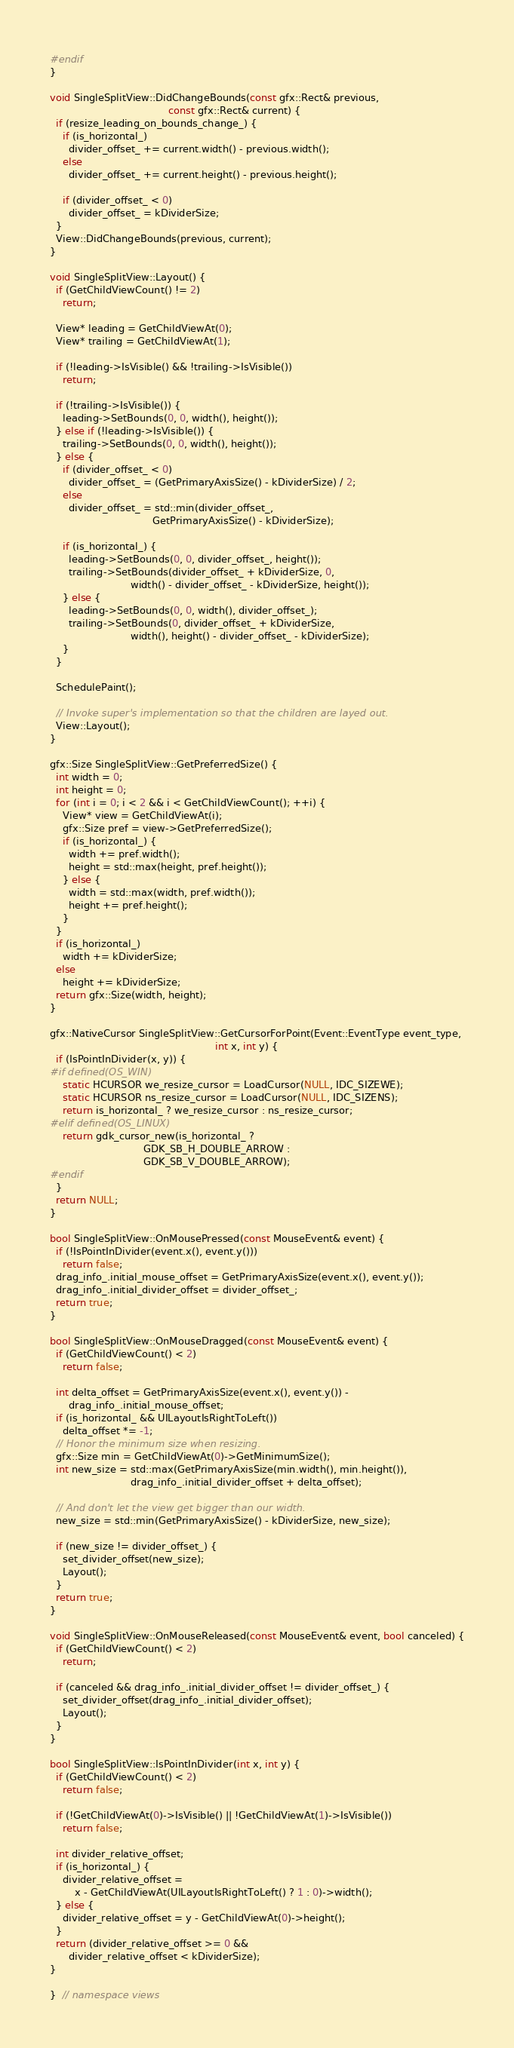<code> <loc_0><loc_0><loc_500><loc_500><_C++_>#endif
}

void SingleSplitView::DidChangeBounds(const gfx::Rect& previous,
                                      const gfx::Rect& current) {
  if (resize_leading_on_bounds_change_) {
    if (is_horizontal_)
      divider_offset_ += current.width() - previous.width();
    else
      divider_offset_ += current.height() - previous.height();

    if (divider_offset_ < 0)
      divider_offset_ = kDividerSize;
  }
  View::DidChangeBounds(previous, current);
}

void SingleSplitView::Layout() {
  if (GetChildViewCount() != 2)
    return;

  View* leading = GetChildViewAt(0);
  View* trailing = GetChildViewAt(1);

  if (!leading->IsVisible() && !trailing->IsVisible())
    return;

  if (!trailing->IsVisible()) {
    leading->SetBounds(0, 0, width(), height());
  } else if (!leading->IsVisible()) {
    trailing->SetBounds(0, 0, width(), height());
  } else {
    if (divider_offset_ < 0)
      divider_offset_ = (GetPrimaryAxisSize() - kDividerSize) / 2;
    else
      divider_offset_ = std::min(divider_offset_,
                                 GetPrimaryAxisSize() - kDividerSize);

    if (is_horizontal_) {
      leading->SetBounds(0, 0, divider_offset_, height());
      trailing->SetBounds(divider_offset_ + kDividerSize, 0,
                          width() - divider_offset_ - kDividerSize, height());
    } else {
      leading->SetBounds(0, 0, width(), divider_offset_);
      trailing->SetBounds(0, divider_offset_ + kDividerSize,
                          width(), height() - divider_offset_ - kDividerSize);
    }
  }

  SchedulePaint();

  // Invoke super's implementation so that the children are layed out.
  View::Layout();
}

gfx::Size SingleSplitView::GetPreferredSize() {
  int width = 0;
  int height = 0;
  for (int i = 0; i < 2 && i < GetChildViewCount(); ++i) {
    View* view = GetChildViewAt(i);
    gfx::Size pref = view->GetPreferredSize();
    if (is_horizontal_) {
      width += pref.width();
      height = std::max(height, pref.height());
    } else {
      width = std::max(width, pref.width());
      height += pref.height();
    }
  }
  if (is_horizontal_)
    width += kDividerSize;
  else
    height += kDividerSize;
  return gfx::Size(width, height);
}

gfx::NativeCursor SingleSplitView::GetCursorForPoint(Event::EventType event_type,
                                                     int x, int y) {
  if (IsPointInDivider(x, y)) {
#if defined(OS_WIN)
    static HCURSOR we_resize_cursor = LoadCursor(NULL, IDC_SIZEWE);
    static HCURSOR ns_resize_cursor = LoadCursor(NULL, IDC_SIZENS);
    return is_horizontal_ ? we_resize_cursor : ns_resize_cursor;
#elif defined(OS_LINUX)
    return gdk_cursor_new(is_horizontal_ ?
                              GDK_SB_H_DOUBLE_ARROW :
                              GDK_SB_V_DOUBLE_ARROW);
#endif
  }
  return NULL;
}

bool SingleSplitView::OnMousePressed(const MouseEvent& event) {
  if (!IsPointInDivider(event.x(), event.y()))
    return false;
  drag_info_.initial_mouse_offset = GetPrimaryAxisSize(event.x(), event.y());
  drag_info_.initial_divider_offset = divider_offset_;
  return true;
}

bool SingleSplitView::OnMouseDragged(const MouseEvent& event) {
  if (GetChildViewCount() < 2)
    return false;

  int delta_offset = GetPrimaryAxisSize(event.x(), event.y()) -
      drag_info_.initial_mouse_offset;
  if (is_horizontal_ && UILayoutIsRightToLeft())
    delta_offset *= -1;
  // Honor the minimum size when resizing.
  gfx::Size min = GetChildViewAt(0)->GetMinimumSize();
  int new_size = std::max(GetPrimaryAxisSize(min.width(), min.height()),
                          drag_info_.initial_divider_offset + delta_offset);

  // And don't let the view get bigger than our width.
  new_size = std::min(GetPrimaryAxisSize() - kDividerSize, new_size);

  if (new_size != divider_offset_) {
    set_divider_offset(new_size);
    Layout();
  }
  return true;
}

void SingleSplitView::OnMouseReleased(const MouseEvent& event, bool canceled) {
  if (GetChildViewCount() < 2)
    return;

  if (canceled && drag_info_.initial_divider_offset != divider_offset_) {
    set_divider_offset(drag_info_.initial_divider_offset);
    Layout();
  }
}

bool SingleSplitView::IsPointInDivider(int x, int y) {
  if (GetChildViewCount() < 2)
    return false;

  if (!GetChildViewAt(0)->IsVisible() || !GetChildViewAt(1)->IsVisible())
    return false;

  int divider_relative_offset;
  if (is_horizontal_) {
    divider_relative_offset =
        x - GetChildViewAt(UILayoutIsRightToLeft() ? 1 : 0)->width();
  } else {
    divider_relative_offset = y - GetChildViewAt(0)->height();
  }
  return (divider_relative_offset >= 0 &&
      divider_relative_offset < kDividerSize);
}

}  // namespace views
</code> 